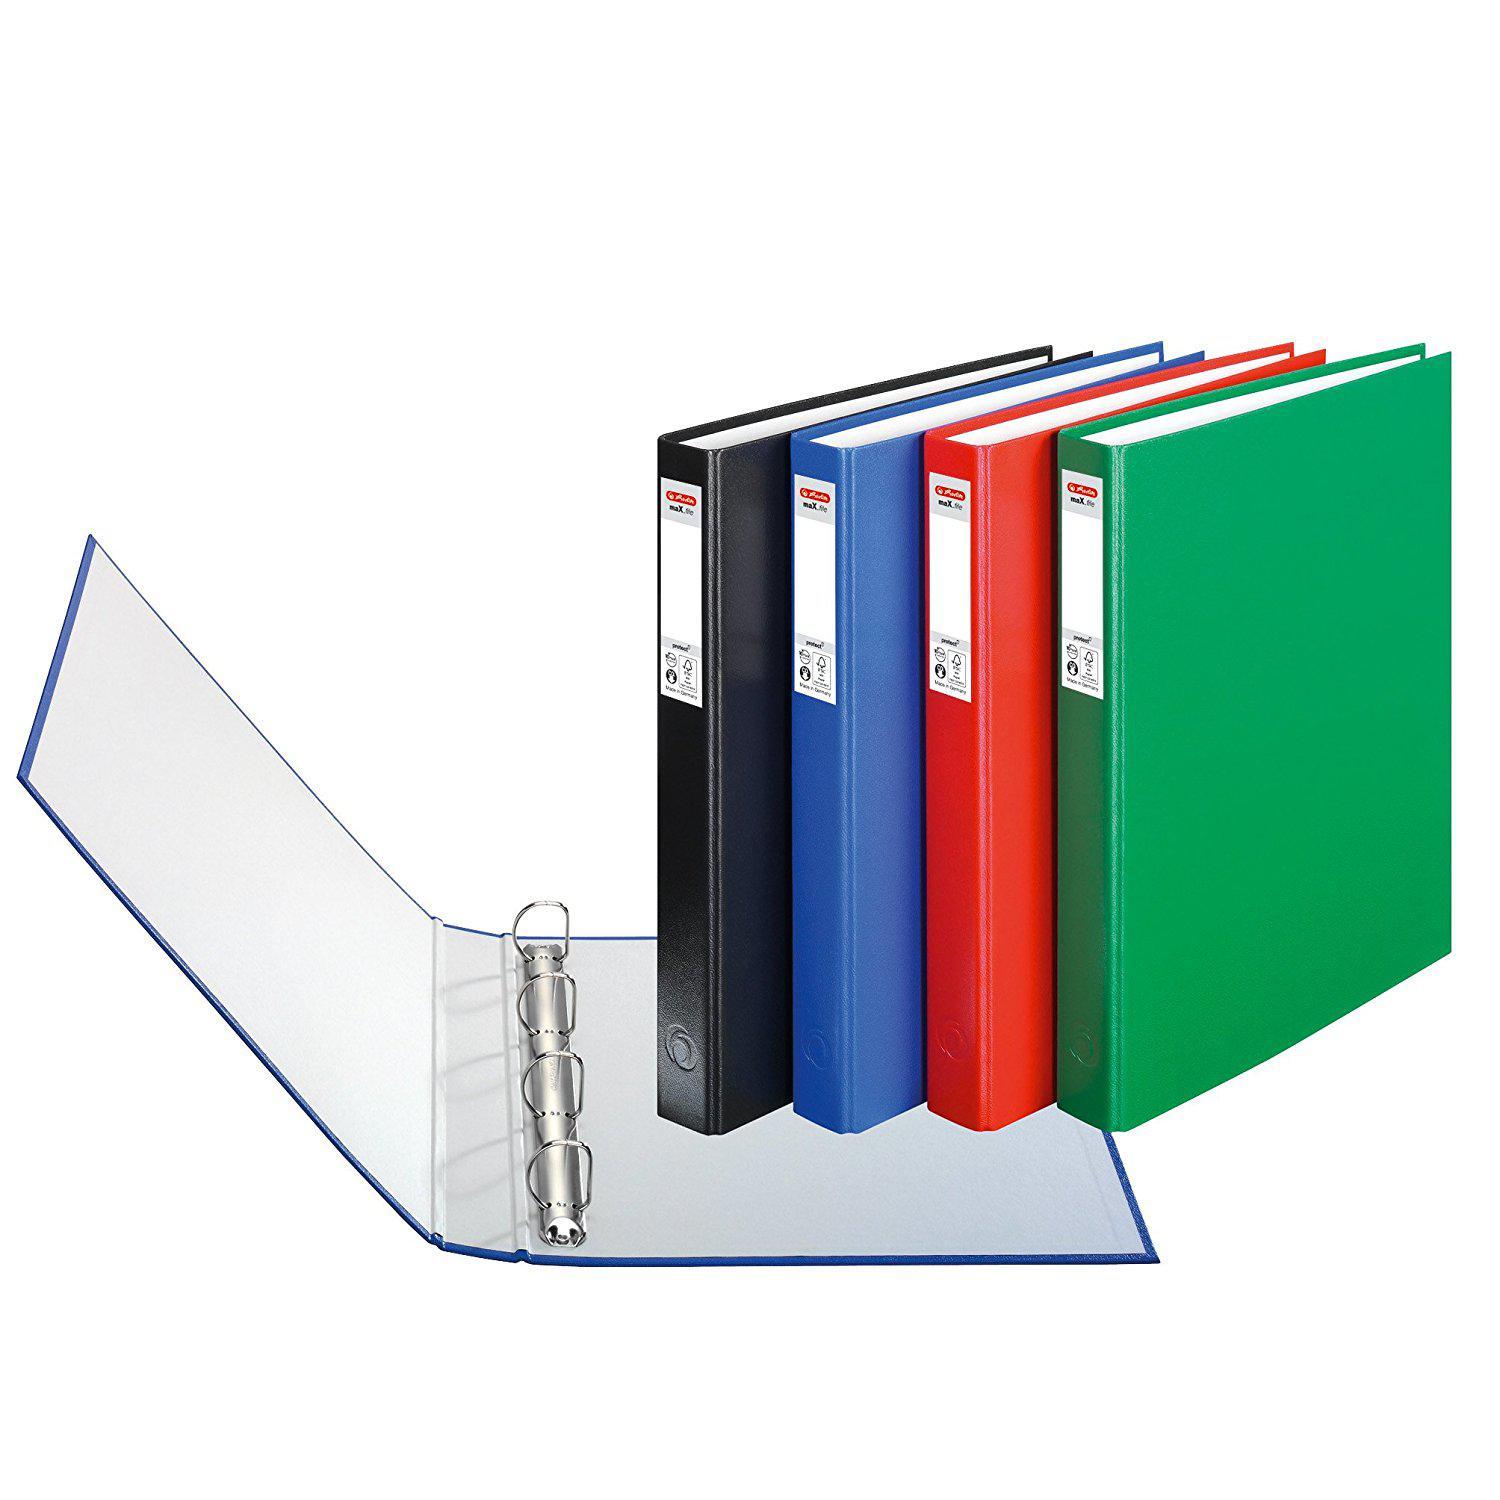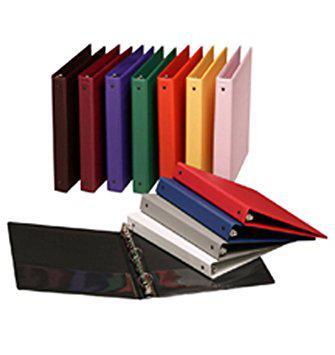The first image is the image on the left, the second image is the image on the right. Evaluate the accuracy of this statement regarding the images: "binders are stacked on their sides with paper inside". Is it true? Answer yes or no. No. 